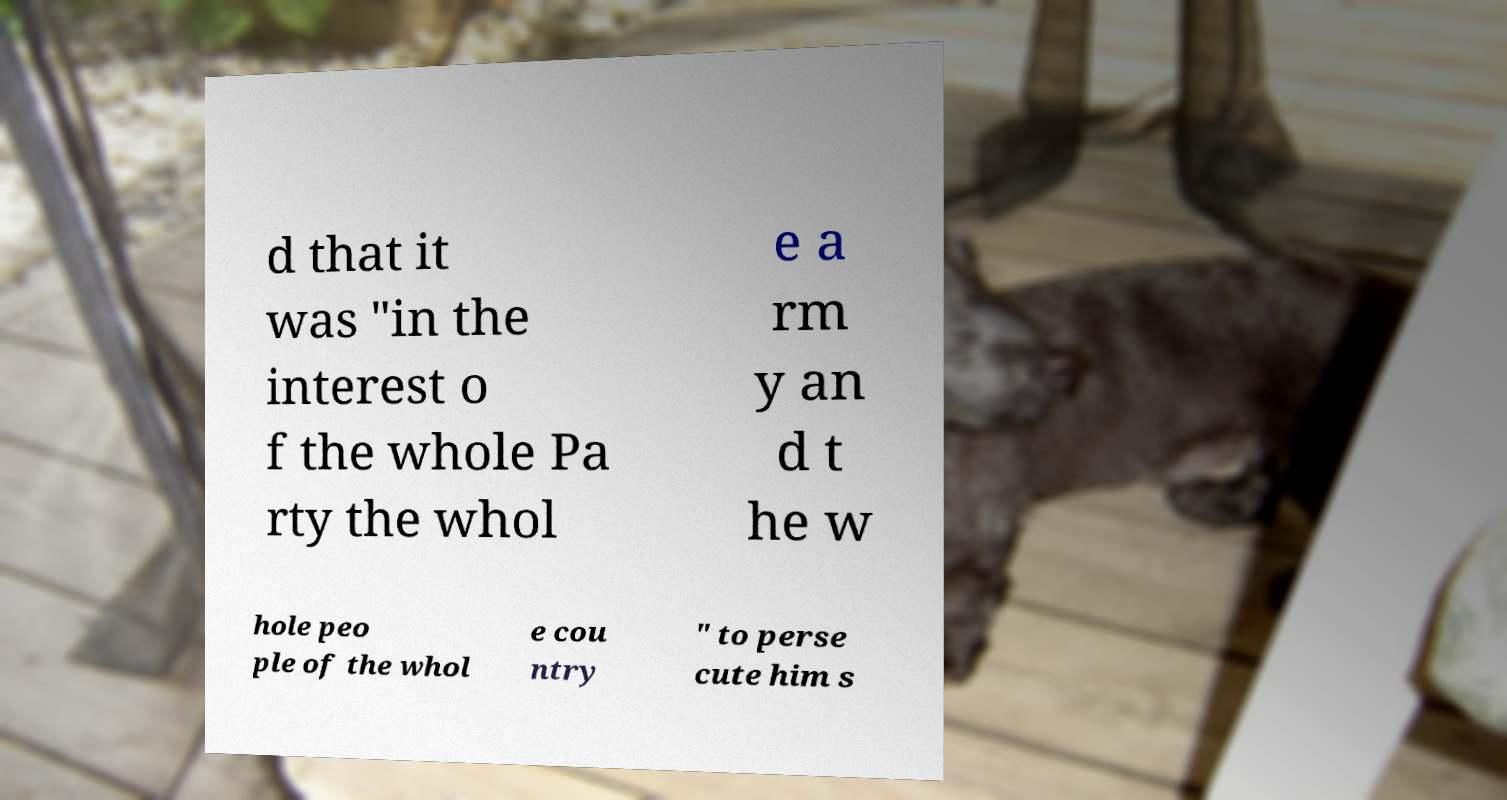For documentation purposes, I need the text within this image transcribed. Could you provide that? d that it was "in the interest o f the whole Pa rty the whol e a rm y an d t he w hole peo ple of the whol e cou ntry " to perse cute him s 